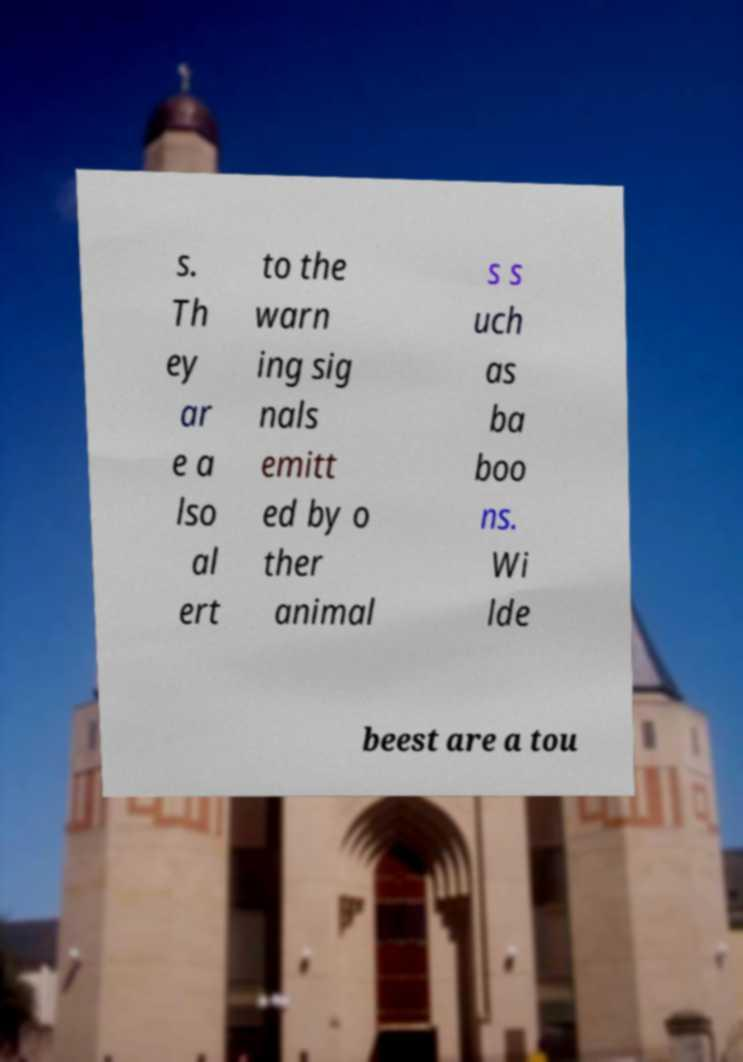For documentation purposes, I need the text within this image transcribed. Could you provide that? s. Th ey ar e a lso al ert to the warn ing sig nals emitt ed by o ther animal s s uch as ba boo ns. Wi lde beest are a tou 